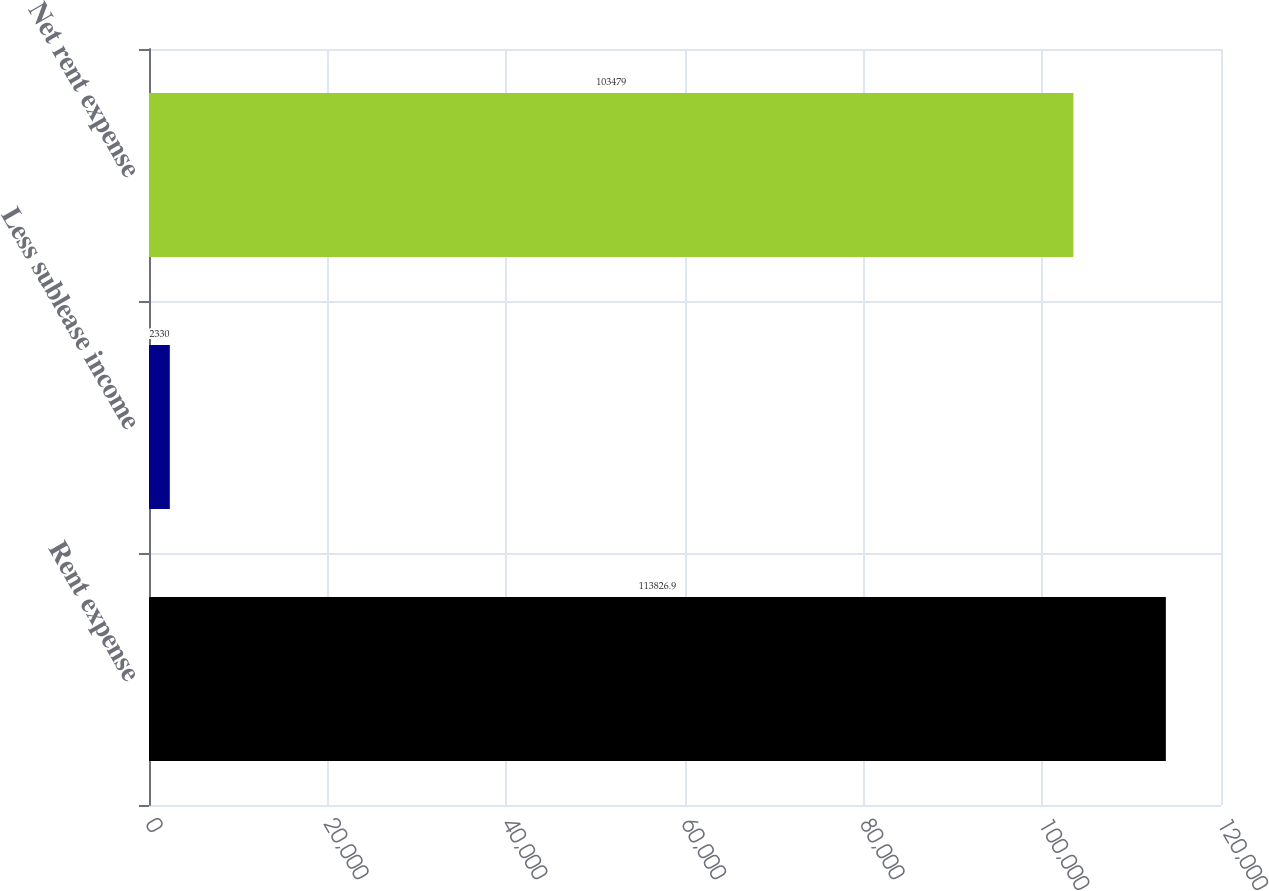Convert chart to OTSL. <chart><loc_0><loc_0><loc_500><loc_500><bar_chart><fcel>Rent expense<fcel>Less sublease income<fcel>Net rent expense<nl><fcel>113827<fcel>2330<fcel>103479<nl></chart> 